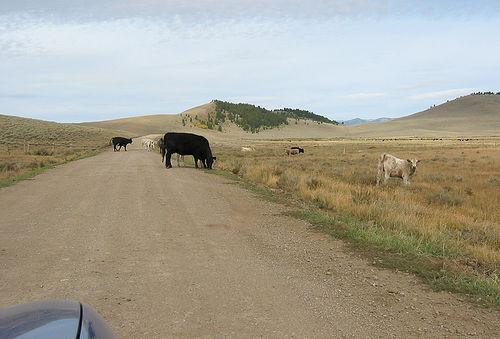Is it daytime?
Be succinct. Yes. DO they need rain?
Answer briefly. Yes. Where are the cows going?
Concise answer only. Pasture. 